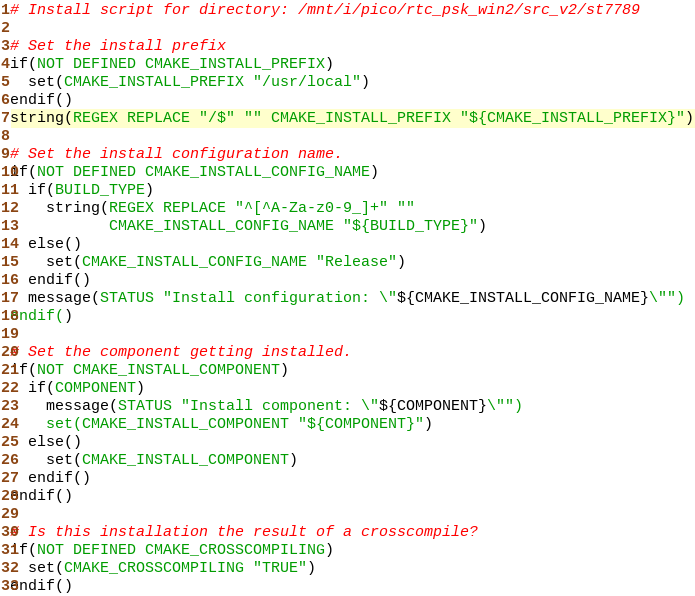Convert code to text. <code><loc_0><loc_0><loc_500><loc_500><_CMake_># Install script for directory: /mnt/i/pico/rtc_psk_win2/src_v2/st7789

# Set the install prefix
if(NOT DEFINED CMAKE_INSTALL_PREFIX)
  set(CMAKE_INSTALL_PREFIX "/usr/local")
endif()
string(REGEX REPLACE "/$" "" CMAKE_INSTALL_PREFIX "${CMAKE_INSTALL_PREFIX}")

# Set the install configuration name.
if(NOT DEFINED CMAKE_INSTALL_CONFIG_NAME)
  if(BUILD_TYPE)
    string(REGEX REPLACE "^[^A-Za-z0-9_]+" ""
           CMAKE_INSTALL_CONFIG_NAME "${BUILD_TYPE}")
  else()
    set(CMAKE_INSTALL_CONFIG_NAME "Release")
  endif()
  message(STATUS "Install configuration: \"${CMAKE_INSTALL_CONFIG_NAME}\"")
endif()

# Set the component getting installed.
if(NOT CMAKE_INSTALL_COMPONENT)
  if(COMPONENT)
    message(STATUS "Install component: \"${COMPONENT}\"")
    set(CMAKE_INSTALL_COMPONENT "${COMPONENT}")
  else()
    set(CMAKE_INSTALL_COMPONENT)
  endif()
endif()

# Is this installation the result of a crosscompile?
if(NOT DEFINED CMAKE_CROSSCOMPILING)
  set(CMAKE_CROSSCOMPILING "TRUE")
endif()

</code> 